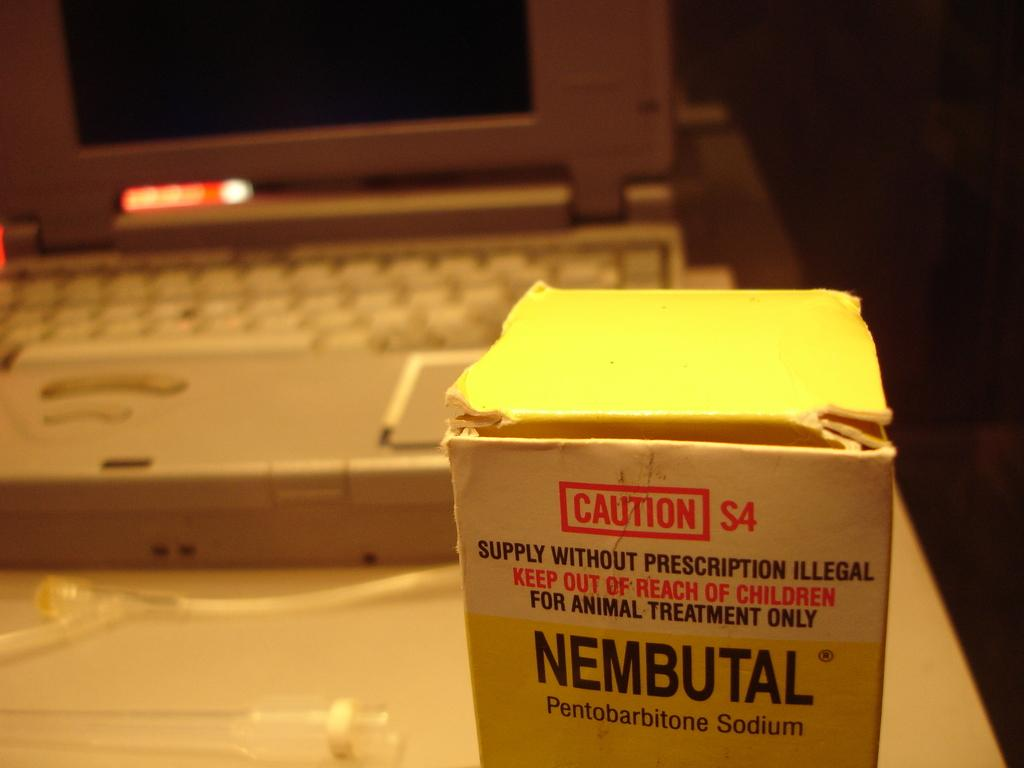<image>
Describe the image concisely. A white box with the word NEMBUTAL on it is in front of a gray laptop on a table. 